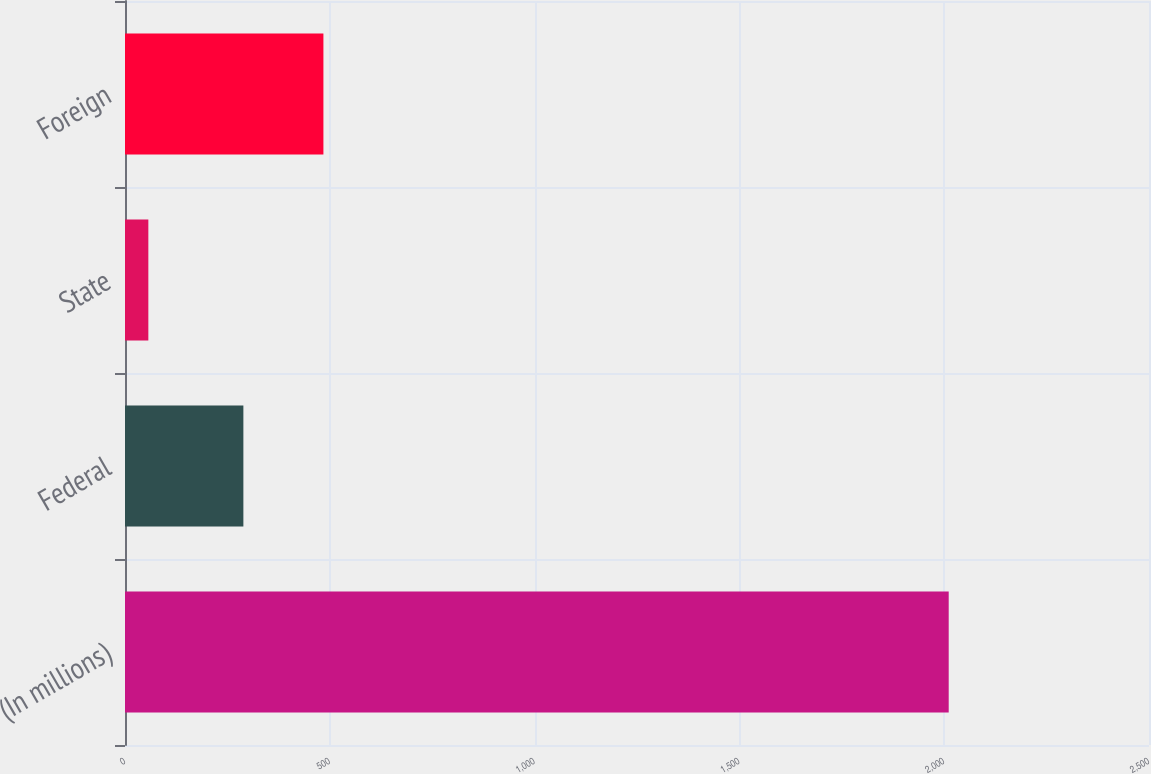Convert chart to OTSL. <chart><loc_0><loc_0><loc_500><loc_500><bar_chart><fcel>(In millions)<fcel>Federal<fcel>State<fcel>Foreign<nl><fcel>2011<fcel>289<fcel>57<fcel>484.4<nl></chart> 